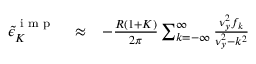Convert formula to latex. <formula><loc_0><loc_0><loc_500><loc_500>\begin{array} { r l r } { { \tilde { \epsilon } } _ { K } ^ { i m p } } & \approx } & { - \frac { R ( 1 + K ) } { 2 \pi } \sum _ { k = - \infty } ^ { \infty } \frac { \nu _ { y } ^ { 2 } f _ { k } } { \nu _ { y } ^ { 2 } - k ^ { 2 } } } \end{array}</formula> 